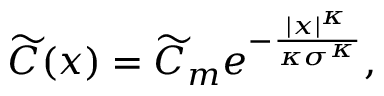Convert formula to latex. <formula><loc_0><loc_0><loc_500><loc_500>\widetilde { C } ( x ) = \widetilde { C } _ { m } e ^ { - \frac { | x | ^ { \kappa } } { \kappa \sigma ^ { \kappa } } } ,</formula> 